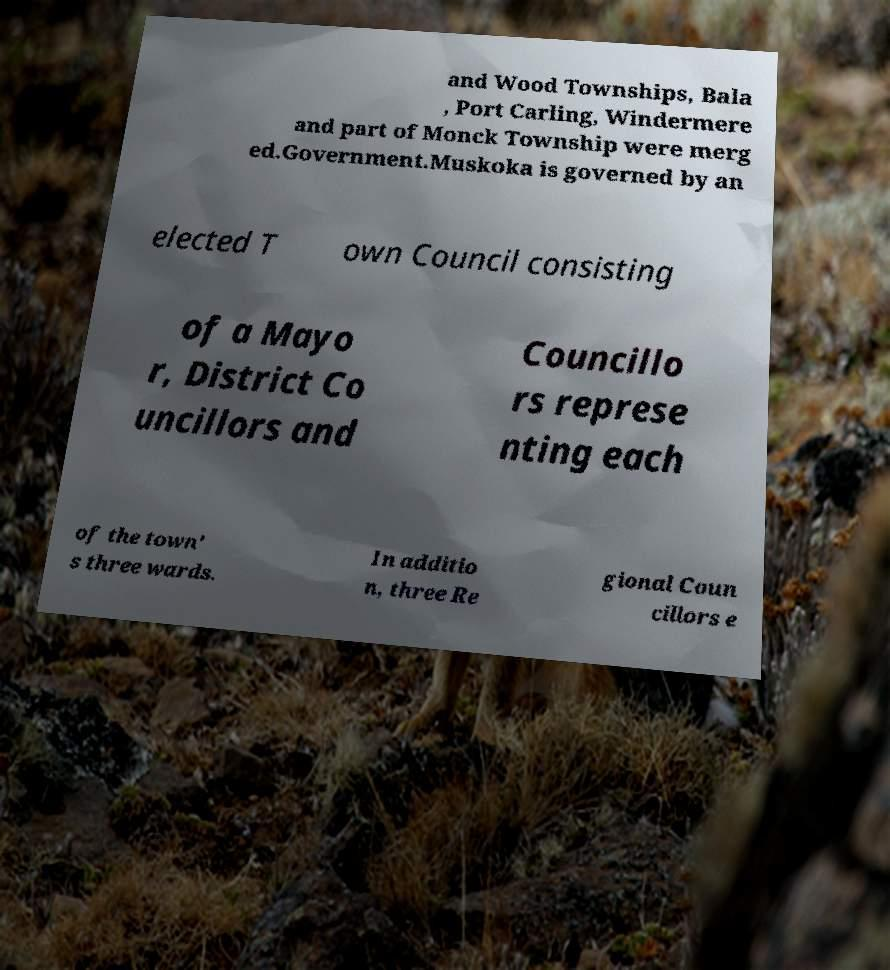Could you extract and type out the text from this image? and Wood Townships, Bala , Port Carling, Windermere and part of Monck Township were merg ed.Government.Muskoka is governed by an elected T own Council consisting of a Mayo r, District Co uncillors and Councillo rs represe nting each of the town' s three wards. In additio n, three Re gional Coun cillors e 